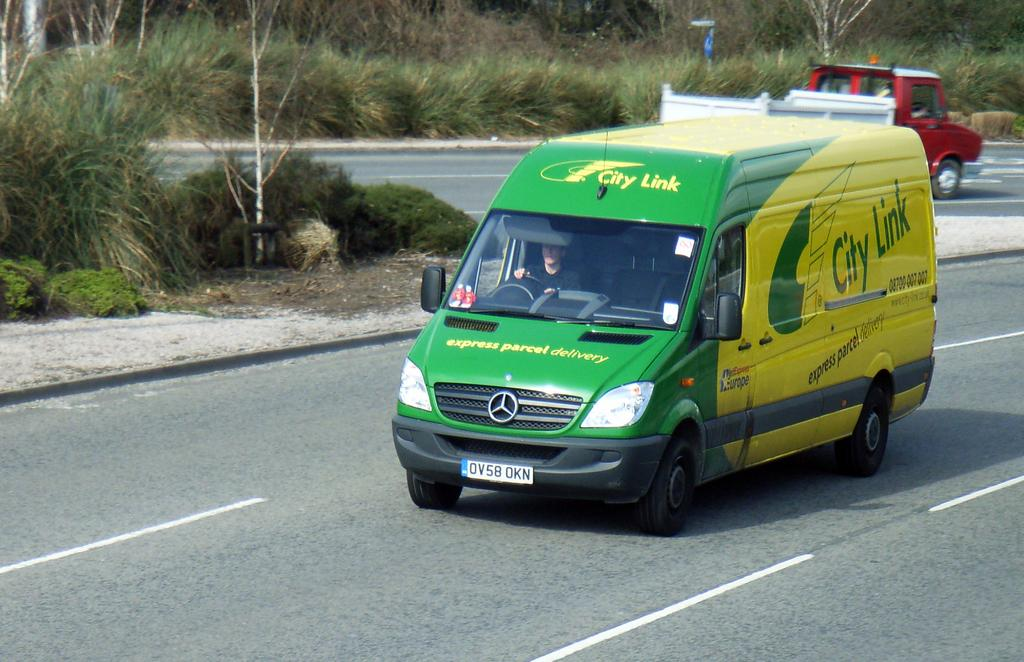What type of vehicles can be seen on the road in the image? There are motor vehicles on the road in the image. What other elements can be seen in the image besides the motor vehicles? There are bushes visible in the image. What type of badge is being worn by the motor vehicles in the image? There are no badges visible on the motor vehicles in the image. What type of fuel is being used by the motor vehicles in the image? The type of fuel being used by the motor vehicles cannot be determined from the image. 